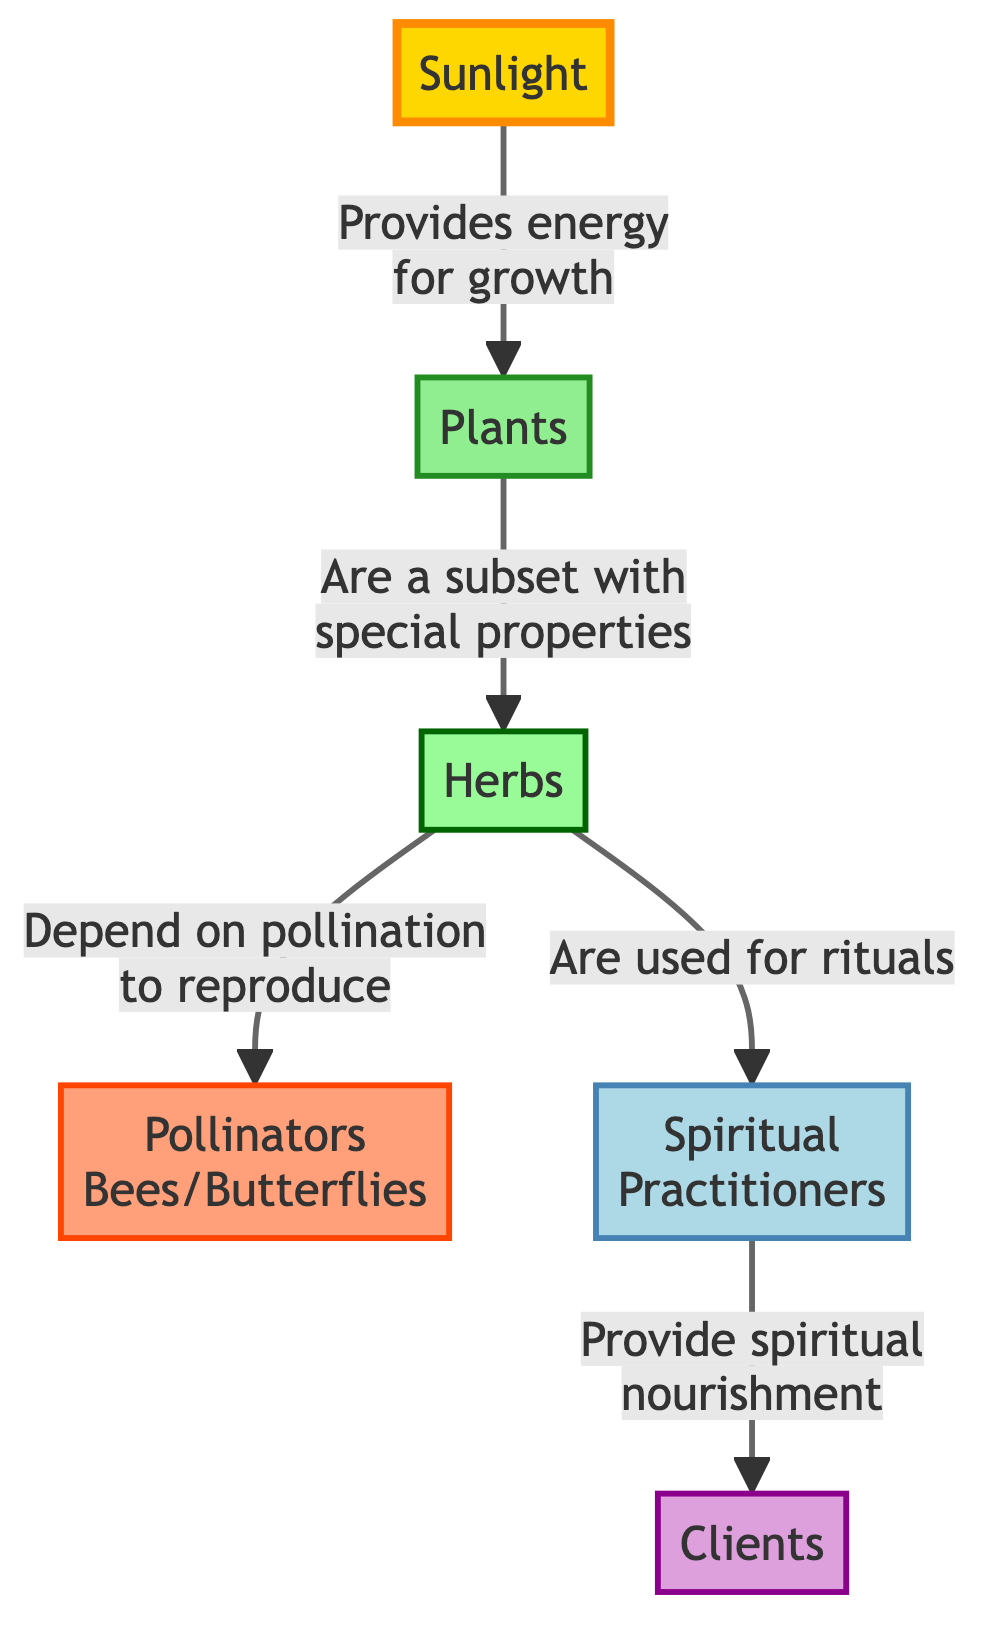What is the first node in the diagram? The first node is labeled "Sunlight," which is the starting point for the energy flow in the diagram.
Answer: Sunlight How many nodes are there in total? There are 6 nodes in the diagram: Sunlight, Plants, Herbs, Pollinators, Spiritual Practitioners, and Clients.
Answer: 6 What do the Plants depend on for growth? According to the diagram, plants depend on sunlight for energy and growth.
Answer: Sunlight What role do Herbs play in the spiritual community garden? Herbs are used for rituals and depend on pollination to reproduce, as indicated in the connections from both Pollinators and Spiritual Practitioners.
Answer: Used for rituals Who provides spiritual nourishment to Clients? The Spiritual Practitioners provide spiritual nourishment to Clients, as depicted in the directed flow from Spiritual Practitioners to Clients.
Answer: Spiritual Practitioners Which node represents the pollinators in the food chain? The node labeled "Pollinators" represents bees and butterflies, and their role is indicated in the connections related to reproduction of Herbs.
Answer: Pollinators What is the connection between Herbs and Pollinators? The connection indicates that Herbs depend on pollinators to reproduce, which shows a relationship of necessity for the reproduction cycle.
Answer: Depend on pollination How does energy flow from the Plants to the Spiritual Practitioners? The flow from Plants to Spiritual Practitioners is indirect; it follows that Herbs, which are a subset of Plants, are utilized by Spiritual Practitioners for rituals. Hence, the energy flow transitions from Plants to Herbs and then to Spiritual Practitioners.
Answer: Through Herbs What is the special property of Herbs compared to Plants? Herbs are indicated as a subset of Plants with special properties, which means they have distinct features or uses within the context of the garden.
Answer: Special properties 